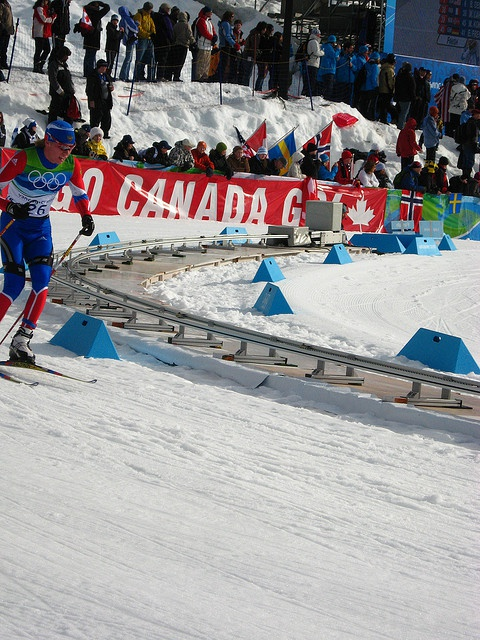Describe the objects in this image and their specific colors. I can see people in black, gray, darkgray, and lightgray tones, people in black, navy, maroon, and gray tones, people in black, gray, darkgray, and maroon tones, people in black, gray, darkgray, and lightgray tones, and people in black, navy, and blue tones in this image. 